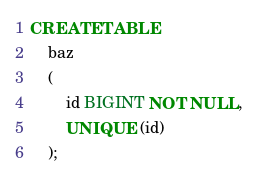Convert code to text. <code><loc_0><loc_0><loc_500><loc_500><_SQL_>CREATE TABLE
    baz
    (
        id BIGINT NOT NULL,
        UNIQUE (id)
    );</code> 